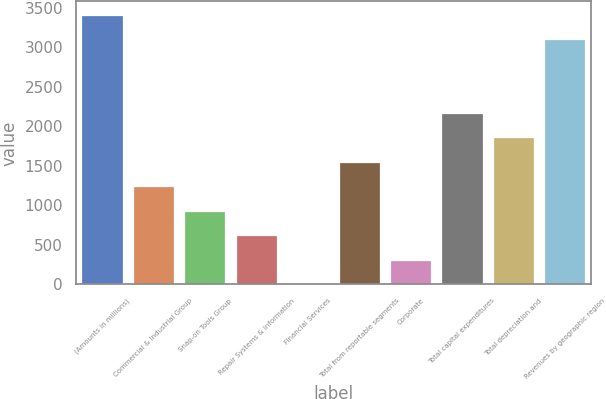Convert chart. <chart><loc_0><loc_0><loc_500><loc_500><bar_chart><fcel>(Amounts in millions)<fcel>Commercial & Industrial Group<fcel>Snap-on Tools Group<fcel>Repair Systems & Information<fcel>Financial Services<fcel>Total from reportable segments<fcel>Corporate<fcel>Total capital expenditures<fcel>Total depreciation and<fcel>Revenues by geographic region<nl><fcel>3408.96<fcel>1240.64<fcel>930.88<fcel>621.12<fcel>1.6<fcel>1550.4<fcel>311.36<fcel>2169.92<fcel>1860.16<fcel>3099.2<nl></chart> 